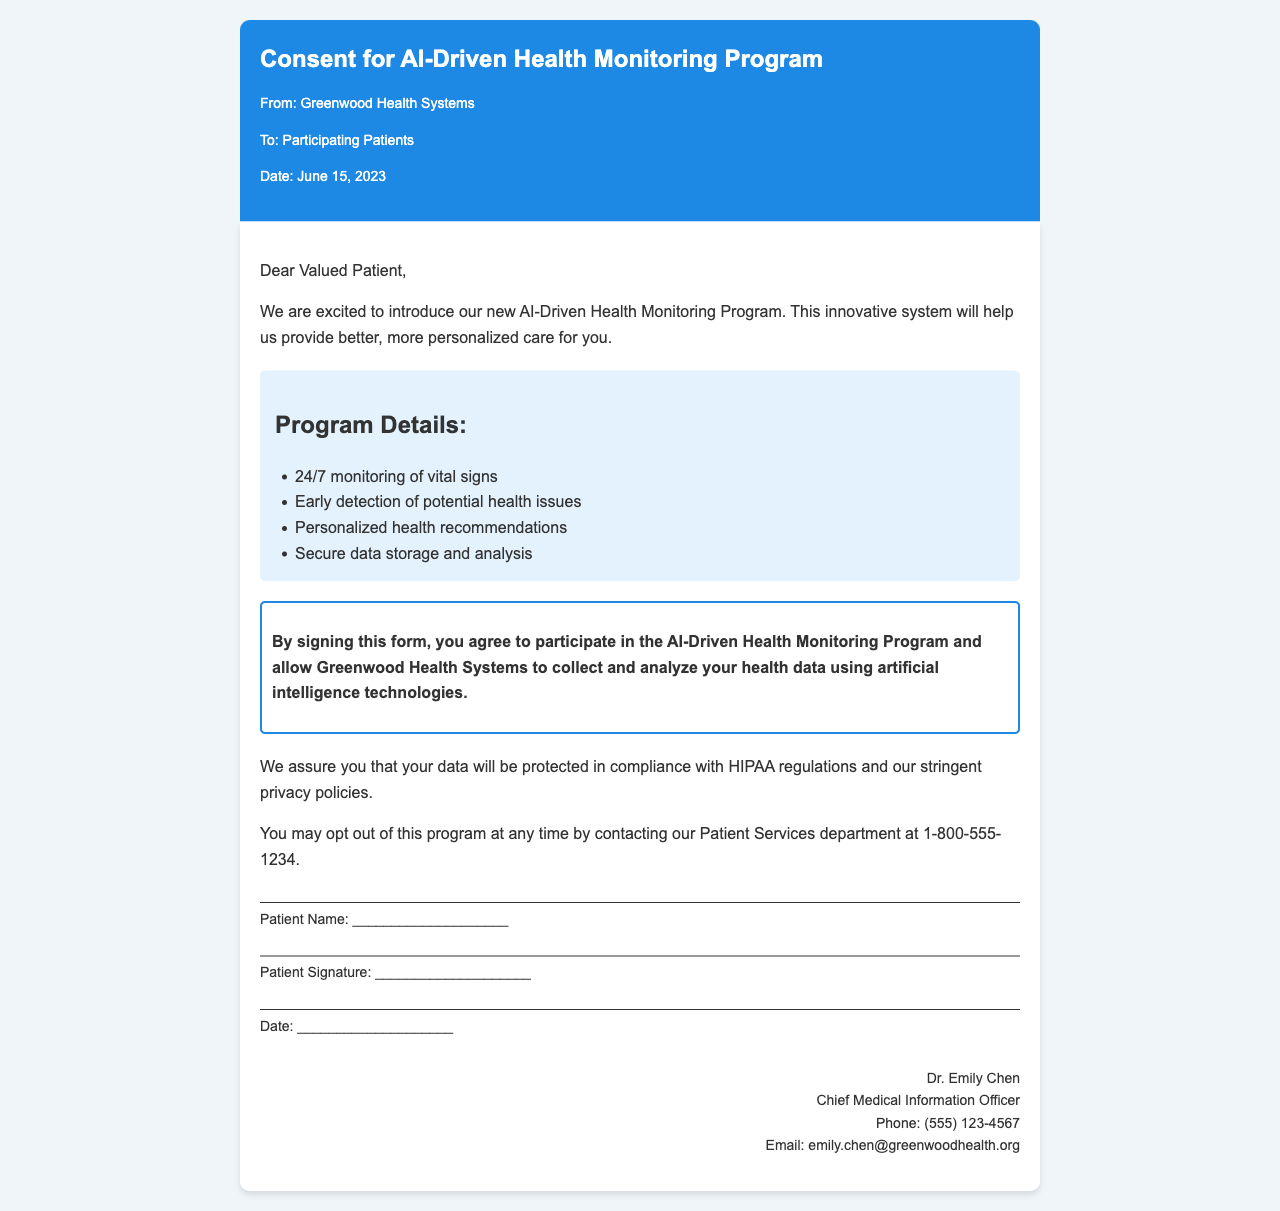What is the title of the document? The title is presented prominently at the top of the document.
Answer: Consent for AI-Driven Health Monitoring Program Who is the sender of the fax? The sender's name is indicated in the header section of the document.
Answer: Greenwood Health Systems What is the date of the fax? The date is stated in the header details of the document.
Answer: June 15, 2023 What is one of the benefits of the program? The document lists several benefits in a dedicated section.
Answer: Early detection of potential health issues What must a patient do to participate in the program? The consent for participation is outlined in the statement within the document.
Answer: Sign the form Who can patients contact to opt out of the program? The document specifies which department to contact for opting out.
Answer: Patient Services department What is the phone number for Dr. Emily Chen? The document provides a direct contact number for Dr. Chen in the contact information section.
Answer: (555) 123-4567 What is the privacy compliance mentioned in the document? The document ensures compliance with regulations regarding data protection.
Answer: HIPAA regulations What is the role of Dr. Emily Chen? The document mentions Dr. Chen's professional title.
Answer: Chief Medical Information Officer 